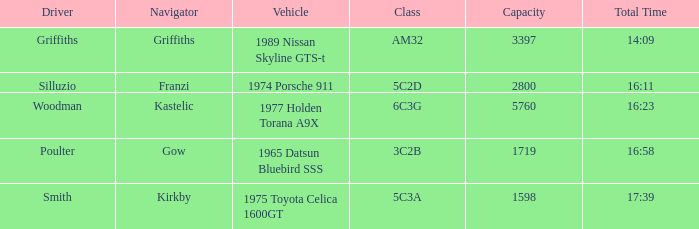Would you mind parsing the complete table? {'header': ['Driver', 'Navigator', 'Vehicle', 'Class', 'Capacity', 'Total Time'], 'rows': [['Griffiths', 'Griffiths', '1989 Nissan Skyline GTS-t', 'AM32', '3397', '14:09'], ['Silluzio', 'Franzi', '1974 Porsche 911', '5C2D', '2800', '16:11'], ['Woodman', 'Kastelic', '1977 Holden Torana A9X', '6C3G', '5760', '16:23'], ['Poulter', 'Gow', '1965 Datsun Bluebird SSS', '3C2B', '1719', '16:58'], ['Smith', 'Kirkby', '1975 Toyota Celica 1600GT', '5C3A', '1598', '17:39']]} What is the minimum capacity when the margin is 03:30? 1598.0. 